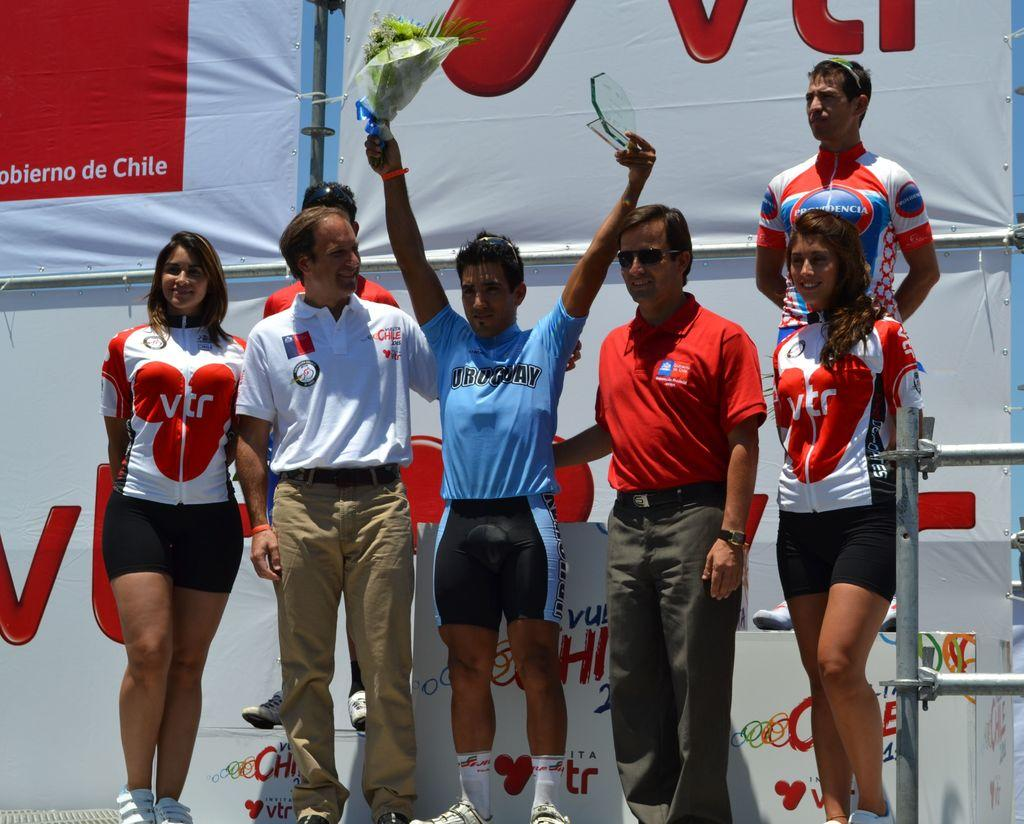Provide a one-sentence caption for the provided image. A player in Chile holds up a trophy and flowers while standing with his team VTR. 